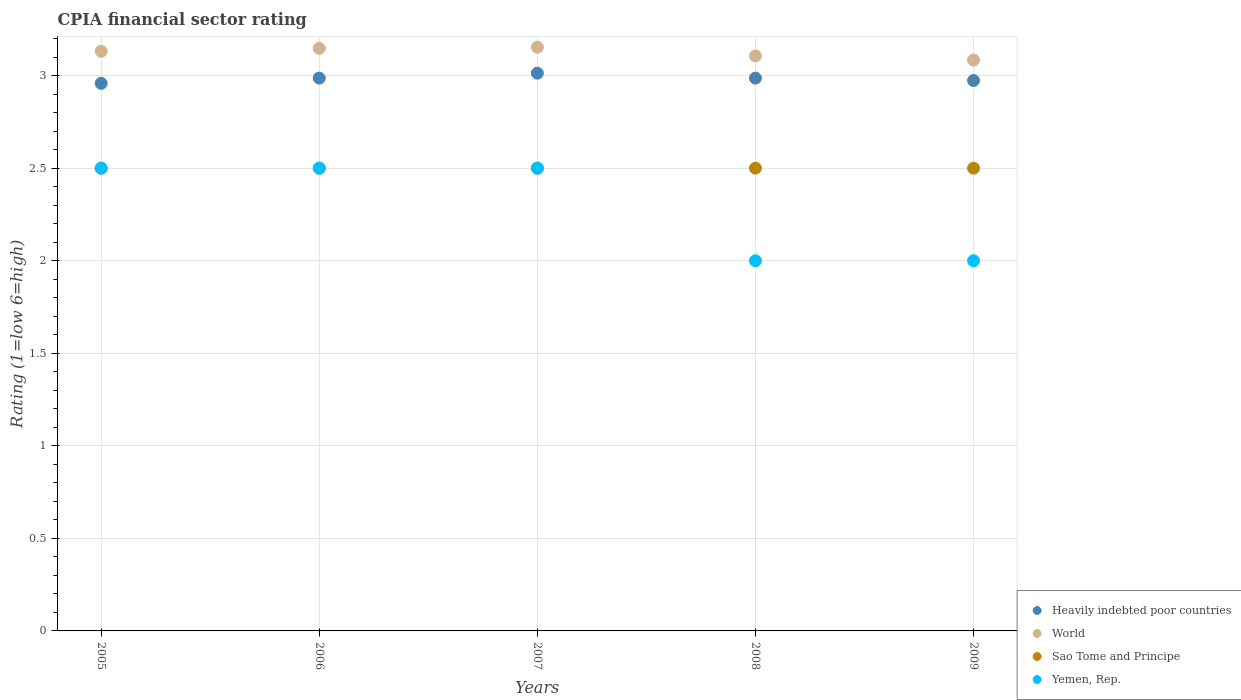Is the number of dotlines equal to the number of legend labels?
Provide a short and direct response. Yes. What is the CPIA rating in Yemen, Rep. in 2008?
Provide a succinct answer. 2. Across all years, what is the maximum CPIA rating in World?
Provide a short and direct response. 3.15. Across all years, what is the minimum CPIA rating in World?
Offer a very short reply. 3.08. In which year was the CPIA rating in World maximum?
Your response must be concise. 2007. In which year was the CPIA rating in Sao Tome and Principe minimum?
Make the answer very short. 2005. What is the total CPIA rating in World in the graph?
Provide a short and direct response. 15.62. What is the difference between the CPIA rating in Yemen, Rep. in 2006 and that in 2008?
Your answer should be compact. 0.5. What is the difference between the CPIA rating in World in 2007 and the CPIA rating in Yemen, Rep. in 2009?
Your answer should be compact. 1.15. In the year 2009, what is the difference between the CPIA rating in Heavily indebted poor countries and CPIA rating in World?
Give a very brief answer. -0.11. In how many years, is the CPIA rating in Yemen, Rep. greater than 1.2?
Your response must be concise. 5. What is the ratio of the CPIA rating in Yemen, Rep. in 2008 to that in 2009?
Offer a very short reply. 1. Is the CPIA rating in World in 2005 less than that in 2006?
Provide a short and direct response. Yes. What is the difference between the highest and the second highest CPIA rating in Heavily indebted poor countries?
Give a very brief answer. 0.03. What is the difference between the highest and the lowest CPIA rating in World?
Offer a very short reply. 0.07. Is it the case that in every year, the sum of the CPIA rating in World and CPIA rating in Heavily indebted poor countries  is greater than the sum of CPIA rating in Yemen, Rep. and CPIA rating in Sao Tome and Principe?
Ensure brevity in your answer.  No. Is the CPIA rating in Yemen, Rep. strictly greater than the CPIA rating in World over the years?
Your answer should be compact. No. Is the CPIA rating in Heavily indebted poor countries strictly less than the CPIA rating in Yemen, Rep. over the years?
Your answer should be compact. No. What is the difference between two consecutive major ticks on the Y-axis?
Offer a terse response. 0.5. Are the values on the major ticks of Y-axis written in scientific E-notation?
Make the answer very short. No. Does the graph contain grids?
Offer a terse response. Yes. Where does the legend appear in the graph?
Your response must be concise. Bottom right. How many legend labels are there?
Your response must be concise. 4. What is the title of the graph?
Provide a short and direct response. CPIA financial sector rating. What is the Rating (1=low 6=high) of Heavily indebted poor countries in 2005?
Your answer should be compact. 2.96. What is the Rating (1=low 6=high) in World in 2005?
Offer a terse response. 3.13. What is the Rating (1=low 6=high) of Sao Tome and Principe in 2005?
Provide a short and direct response. 2.5. What is the Rating (1=low 6=high) of Yemen, Rep. in 2005?
Offer a very short reply. 2.5. What is the Rating (1=low 6=high) in Heavily indebted poor countries in 2006?
Ensure brevity in your answer.  2.99. What is the Rating (1=low 6=high) of World in 2006?
Ensure brevity in your answer.  3.15. What is the Rating (1=low 6=high) in Sao Tome and Principe in 2006?
Ensure brevity in your answer.  2.5. What is the Rating (1=low 6=high) of Yemen, Rep. in 2006?
Your response must be concise. 2.5. What is the Rating (1=low 6=high) in Heavily indebted poor countries in 2007?
Ensure brevity in your answer.  3.01. What is the Rating (1=low 6=high) of World in 2007?
Your answer should be compact. 3.15. What is the Rating (1=low 6=high) of Sao Tome and Principe in 2007?
Provide a short and direct response. 2.5. What is the Rating (1=low 6=high) in Heavily indebted poor countries in 2008?
Keep it short and to the point. 2.99. What is the Rating (1=low 6=high) of World in 2008?
Provide a succinct answer. 3.11. What is the Rating (1=low 6=high) in Yemen, Rep. in 2008?
Make the answer very short. 2. What is the Rating (1=low 6=high) in Heavily indebted poor countries in 2009?
Ensure brevity in your answer.  2.97. What is the Rating (1=low 6=high) in World in 2009?
Offer a very short reply. 3.08. What is the Rating (1=low 6=high) in Yemen, Rep. in 2009?
Your response must be concise. 2. Across all years, what is the maximum Rating (1=low 6=high) of Heavily indebted poor countries?
Your response must be concise. 3.01. Across all years, what is the maximum Rating (1=low 6=high) in World?
Make the answer very short. 3.15. Across all years, what is the minimum Rating (1=low 6=high) of Heavily indebted poor countries?
Give a very brief answer. 2.96. Across all years, what is the minimum Rating (1=low 6=high) of World?
Offer a terse response. 3.08. Across all years, what is the minimum Rating (1=low 6=high) in Sao Tome and Principe?
Give a very brief answer. 2.5. What is the total Rating (1=low 6=high) of Heavily indebted poor countries in the graph?
Make the answer very short. 14.92. What is the total Rating (1=low 6=high) in World in the graph?
Make the answer very short. 15.62. What is the difference between the Rating (1=low 6=high) in Heavily indebted poor countries in 2005 and that in 2006?
Make the answer very short. -0.03. What is the difference between the Rating (1=low 6=high) of World in 2005 and that in 2006?
Offer a terse response. -0.02. What is the difference between the Rating (1=low 6=high) in Sao Tome and Principe in 2005 and that in 2006?
Your answer should be very brief. 0. What is the difference between the Rating (1=low 6=high) in Yemen, Rep. in 2005 and that in 2006?
Make the answer very short. 0. What is the difference between the Rating (1=low 6=high) of Heavily indebted poor countries in 2005 and that in 2007?
Offer a very short reply. -0.06. What is the difference between the Rating (1=low 6=high) of World in 2005 and that in 2007?
Provide a succinct answer. -0.02. What is the difference between the Rating (1=low 6=high) in Yemen, Rep. in 2005 and that in 2007?
Offer a very short reply. 0. What is the difference between the Rating (1=low 6=high) in Heavily indebted poor countries in 2005 and that in 2008?
Offer a very short reply. -0.03. What is the difference between the Rating (1=low 6=high) in World in 2005 and that in 2008?
Make the answer very short. 0.02. What is the difference between the Rating (1=low 6=high) in Yemen, Rep. in 2005 and that in 2008?
Ensure brevity in your answer.  0.5. What is the difference between the Rating (1=low 6=high) in Heavily indebted poor countries in 2005 and that in 2009?
Provide a short and direct response. -0.02. What is the difference between the Rating (1=low 6=high) of World in 2005 and that in 2009?
Ensure brevity in your answer.  0.05. What is the difference between the Rating (1=low 6=high) of Sao Tome and Principe in 2005 and that in 2009?
Offer a very short reply. 0. What is the difference between the Rating (1=low 6=high) in Heavily indebted poor countries in 2006 and that in 2007?
Give a very brief answer. -0.03. What is the difference between the Rating (1=low 6=high) of World in 2006 and that in 2007?
Your answer should be very brief. -0.01. What is the difference between the Rating (1=low 6=high) in World in 2006 and that in 2008?
Keep it short and to the point. 0.04. What is the difference between the Rating (1=low 6=high) in Heavily indebted poor countries in 2006 and that in 2009?
Offer a very short reply. 0.01. What is the difference between the Rating (1=low 6=high) of World in 2006 and that in 2009?
Your response must be concise. 0.06. What is the difference between the Rating (1=low 6=high) of Sao Tome and Principe in 2006 and that in 2009?
Offer a terse response. 0. What is the difference between the Rating (1=low 6=high) of Heavily indebted poor countries in 2007 and that in 2008?
Provide a succinct answer. 0.03. What is the difference between the Rating (1=low 6=high) in World in 2007 and that in 2008?
Offer a very short reply. 0.05. What is the difference between the Rating (1=low 6=high) of Yemen, Rep. in 2007 and that in 2008?
Provide a succinct answer. 0.5. What is the difference between the Rating (1=low 6=high) of Heavily indebted poor countries in 2007 and that in 2009?
Your response must be concise. 0.04. What is the difference between the Rating (1=low 6=high) in World in 2007 and that in 2009?
Provide a short and direct response. 0.07. What is the difference between the Rating (1=low 6=high) in Sao Tome and Principe in 2007 and that in 2009?
Keep it short and to the point. 0. What is the difference between the Rating (1=low 6=high) of Heavily indebted poor countries in 2008 and that in 2009?
Offer a terse response. 0.01. What is the difference between the Rating (1=low 6=high) of World in 2008 and that in 2009?
Your response must be concise. 0.02. What is the difference between the Rating (1=low 6=high) in Sao Tome and Principe in 2008 and that in 2009?
Provide a short and direct response. 0. What is the difference between the Rating (1=low 6=high) of Heavily indebted poor countries in 2005 and the Rating (1=low 6=high) of World in 2006?
Provide a short and direct response. -0.19. What is the difference between the Rating (1=low 6=high) in Heavily indebted poor countries in 2005 and the Rating (1=low 6=high) in Sao Tome and Principe in 2006?
Provide a short and direct response. 0.46. What is the difference between the Rating (1=low 6=high) of Heavily indebted poor countries in 2005 and the Rating (1=low 6=high) of Yemen, Rep. in 2006?
Your answer should be very brief. 0.46. What is the difference between the Rating (1=low 6=high) in World in 2005 and the Rating (1=low 6=high) in Sao Tome and Principe in 2006?
Provide a succinct answer. 0.63. What is the difference between the Rating (1=low 6=high) in World in 2005 and the Rating (1=low 6=high) in Yemen, Rep. in 2006?
Give a very brief answer. 0.63. What is the difference between the Rating (1=low 6=high) of Heavily indebted poor countries in 2005 and the Rating (1=low 6=high) of World in 2007?
Offer a very short reply. -0.2. What is the difference between the Rating (1=low 6=high) of Heavily indebted poor countries in 2005 and the Rating (1=low 6=high) of Sao Tome and Principe in 2007?
Keep it short and to the point. 0.46. What is the difference between the Rating (1=low 6=high) in Heavily indebted poor countries in 2005 and the Rating (1=low 6=high) in Yemen, Rep. in 2007?
Offer a terse response. 0.46. What is the difference between the Rating (1=low 6=high) of World in 2005 and the Rating (1=low 6=high) of Sao Tome and Principe in 2007?
Make the answer very short. 0.63. What is the difference between the Rating (1=low 6=high) in World in 2005 and the Rating (1=low 6=high) in Yemen, Rep. in 2007?
Your answer should be compact. 0.63. What is the difference between the Rating (1=low 6=high) of Heavily indebted poor countries in 2005 and the Rating (1=low 6=high) of World in 2008?
Keep it short and to the point. -0.15. What is the difference between the Rating (1=low 6=high) of Heavily indebted poor countries in 2005 and the Rating (1=low 6=high) of Sao Tome and Principe in 2008?
Give a very brief answer. 0.46. What is the difference between the Rating (1=low 6=high) of Heavily indebted poor countries in 2005 and the Rating (1=low 6=high) of Yemen, Rep. in 2008?
Offer a very short reply. 0.96. What is the difference between the Rating (1=low 6=high) in World in 2005 and the Rating (1=low 6=high) in Sao Tome and Principe in 2008?
Give a very brief answer. 0.63. What is the difference between the Rating (1=low 6=high) of World in 2005 and the Rating (1=low 6=high) of Yemen, Rep. in 2008?
Your answer should be compact. 1.13. What is the difference between the Rating (1=low 6=high) in Sao Tome and Principe in 2005 and the Rating (1=low 6=high) in Yemen, Rep. in 2008?
Offer a very short reply. 0.5. What is the difference between the Rating (1=low 6=high) of Heavily indebted poor countries in 2005 and the Rating (1=low 6=high) of World in 2009?
Give a very brief answer. -0.13. What is the difference between the Rating (1=low 6=high) in Heavily indebted poor countries in 2005 and the Rating (1=low 6=high) in Sao Tome and Principe in 2009?
Provide a succinct answer. 0.46. What is the difference between the Rating (1=low 6=high) of World in 2005 and the Rating (1=low 6=high) of Sao Tome and Principe in 2009?
Keep it short and to the point. 0.63. What is the difference between the Rating (1=low 6=high) in World in 2005 and the Rating (1=low 6=high) in Yemen, Rep. in 2009?
Your response must be concise. 1.13. What is the difference between the Rating (1=low 6=high) in Heavily indebted poor countries in 2006 and the Rating (1=low 6=high) in World in 2007?
Keep it short and to the point. -0.17. What is the difference between the Rating (1=low 6=high) in Heavily indebted poor countries in 2006 and the Rating (1=low 6=high) in Sao Tome and Principe in 2007?
Make the answer very short. 0.49. What is the difference between the Rating (1=low 6=high) of Heavily indebted poor countries in 2006 and the Rating (1=low 6=high) of Yemen, Rep. in 2007?
Your response must be concise. 0.49. What is the difference between the Rating (1=low 6=high) of World in 2006 and the Rating (1=low 6=high) of Sao Tome and Principe in 2007?
Keep it short and to the point. 0.65. What is the difference between the Rating (1=low 6=high) of World in 2006 and the Rating (1=low 6=high) of Yemen, Rep. in 2007?
Provide a short and direct response. 0.65. What is the difference between the Rating (1=low 6=high) in Heavily indebted poor countries in 2006 and the Rating (1=low 6=high) in World in 2008?
Keep it short and to the point. -0.12. What is the difference between the Rating (1=low 6=high) of Heavily indebted poor countries in 2006 and the Rating (1=low 6=high) of Sao Tome and Principe in 2008?
Provide a short and direct response. 0.49. What is the difference between the Rating (1=low 6=high) in Heavily indebted poor countries in 2006 and the Rating (1=low 6=high) in Yemen, Rep. in 2008?
Provide a succinct answer. 0.99. What is the difference between the Rating (1=low 6=high) in World in 2006 and the Rating (1=low 6=high) in Sao Tome and Principe in 2008?
Your response must be concise. 0.65. What is the difference between the Rating (1=low 6=high) in World in 2006 and the Rating (1=low 6=high) in Yemen, Rep. in 2008?
Your answer should be compact. 1.15. What is the difference between the Rating (1=low 6=high) of Sao Tome and Principe in 2006 and the Rating (1=low 6=high) of Yemen, Rep. in 2008?
Your answer should be very brief. 0.5. What is the difference between the Rating (1=low 6=high) of Heavily indebted poor countries in 2006 and the Rating (1=low 6=high) of World in 2009?
Offer a terse response. -0.1. What is the difference between the Rating (1=low 6=high) in Heavily indebted poor countries in 2006 and the Rating (1=low 6=high) in Sao Tome and Principe in 2009?
Make the answer very short. 0.49. What is the difference between the Rating (1=low 6=high) in Heavily indebted poor countries in 2006 and the Rating (1=low 6=high) in Yemen, Rep. in 2009?
Keep it short and to the point. 0.99. What is the difference between the Rating (1=low 6=high) of World in 2006 and the Rating (1=low 6=high) of Sao Tome and Principe in 2009?
Your answer should be compact. 0.65. What is the difference between the Rating (1=low 6=high) in World in 2006 and the Rating (1=low 6=high) in Yemen, Rep. in 2009?
Make the answer very short. 1.15. What is the difference between the Rating (1=low 6=high) in Heavily indebted poor countries in 2007 and the Rating (1=low 6=high) in World in 2008?
Ensure brevity in your answer.  -0.09. What is the difference between the Rating (1=low 6=high) of Heavily indebted poor countries in 2007 and the Rating (1=low 6=high) of Sao Tome and Principe in 2008?
Ensure brevity in your answer.  0.51. What is the difference between the Rating (1=low 6=high) in Heavily indebted poor countries in 2007 and the Rating (1=low 6=high) in Yemen, Rep. in 2008?
Give a very brief answer. 1.01. What is the difference between the Rating (1=low 6=high) in World in 2007 and the Rating (1=low 6=high) in Sao Tome and Principe in 2008?
Ensure brevity in your answer.  0.65. What is the difference between the Rating (1=low 6=high) of World in 2007 and the Rating (1=low 6=high) of Yemen, Rep. in 2008?
Provide a succinct answer. 1.15. What is the difference between the Rating (1=low 6=high) in Heavily indebted poor countries in 2007 and the Rating (1=low 6=high) in World in 2009?
Keep it short and to the point. -0.07. What is the difference between the Rating (1=low 6=high) of Heavily indebted poor countries in 2007 and the Rating (1=low 6=high) of Sao Tome and Principe in 2009?
Your answer should be very brief. 0.51. What is the difference between the Rating (1=low 6=high) in Heavily indebted poor countries in 2007 and the Rating (1=low 6=high) in Yemen, Rep. in 2009?
Ensure brevity in your answer.  1.01. What is the difference between the Rating (1=low 6=high) in World in 2007 and the Rating (1=low 6=high) in Sao Tome and Principe in 2009?
Make the answer very short. 0.65. What is the difference between the Rating (1=low 6=high) of World in 2007 and the Rating (1=low 6=high) of Yemen, Rep. in 2009?
Keep it short and to the point. 1.15. What is the difference between the Rating (1=low 6=high) of Heavily indebted poor countries in 2008 and the Rating (1=low 6=high) of World in 2009?
Keep it short and to the point. -0.1. What is the difference between the Rating (1=low 6=high) of Heavily indebted poor countries in 2008 and the Rating (1=low 6=high) of Sao Tome and Principe in 2009?
Offer a very short reply. 0.49. What is the difference between the Rating (1=low 6=high) of Heavily indebted poor countries in 2008 and the Rating (1=low 6=high) of Yemen, Rep. in 2009?
Offer a very short reply. 0.99. What is the difference between the Rating (1=low 6=high) of World in 2008 and the Rating (1=low 6=high) of Sao Tome and Principe in 2009?
Ensure brevity in your answer.  0.61. What is the difference between the Rating (1=low 6=high) in World in 2008 and the Rating (1=low 6=high) in Yemen, Rep. in 2009?
Your answer should be compact. 1.11. What is the difference between the Rating (1=low 6=high) of Sao Tome and Principe in 2008 and the Rating (1=low 6=high) of Yemen, Rep. in 2009?
Keep it short and to the point. 0.5. What is the average Rating (1=low 6=high) of Heavily indebted poor countries per year?
Your response must be concise. 2.98. What is the average Rating (1=low 6=high) of World per year?
Give a very brief answer. 3.12. What is the average Rating (1=low 6=high) in Sao Tome and Principe per year?
Provide a succinct answer. 2.5. In the year 2005, what is the difference between the Rating (1=low 6=high) of Heavily indebted poor countries and Rating (1=low 6=high) of World?
Your answer should be very brief. -0.17. In the year 2005, what is the difference between the Rating (1=low 6=high) of Heavily indebted poor countries and Rating (1=low 6=high) of Sao Tome and Principe?
Offer a very short reply. 0.46. In the year 2005, what is the difference between the Rating (1=low 6=high) in Heavily indebted poor countries and Rating (1=low 6=high) in Yemen, Rep.?
Provide a succinct answer. 0.46. In the year 2005, what is the difference between the Rating (1=low 6=high) of World and Rating (1=low 6=high) of Sao Tome and Principe?
Your answer should be compact. 0.63. In the year 2005, what is the difference between the Rating (1=low 6=high) in World and Rating (1=low 6=high) in Yemen, Rep.?
Ensure brevity in your answer.  0.63. In the year 2005, what is the difference between the Rating (1=low 6=high) in Sao Tome and Principe and Rating (1=low 6=high) in Yemen, Rep.?
Provide a succinct answer. 0. In the year 2006, what is the difference between the Rating (1=low 6=high) of Heavily indebted poor countries and Rating (1=low 6=high) of World?
Offer a terse response. -0.16. In the year 2006, what is the difference between the Rating (1=low 6=high) of Heavily indebted poor countries and Rating (1=low 6=high) of Sao Tome and Principe?
Keep it short and to the point. 0.49. In the year 2006, what is the difference between the Rating (1=low 6=high) of Heavily indebted poor countries and Rating (1=low 6=high) of Yemen, Rep.?
Ensure brevity in your answer.  0.49. In the year 2006, what is the difference between the Rating (1=low 6=high) of World and Rating (1=low 6=high) of Sao Tome and Principe?
Give a very brief answer. 0.65. In the year 2006, what is the difference between the Rating (1=low 6=high) of World and Rating (1=low 6=high) of Yemen, Rep.?
Provide a short and direct response. 0.65. In the year 2007, what is the difference between the Rating (1=low 6=high) of Heavily indebted poor countries and Rating (1=low 6=high) of World?
Provide a succinct answer. -0.14. In the year 2007, what is the difference between the Rating (1=low 6=high) in Heavily indebted poor countries and Rating (1=low 6=high) in Sao Tome and Principe?
Your answer should be compact. 0.51. In the year 2007, what is the difference between the Rating (1=low 6=high) of Heavily indebted poor countries and Rating (1=low 6=high) of Yemen, Rep.?
Ensure brevity in your answer.  0.51. In the year 2007, what is the difference between the Rating (1=low 6=high) in World and Rating (1=low 6=high) in Sao Tome and Principe?
Your answer should be very brief. 0.65. In the year 2007, what is the difference between the Rating (1=low 6=high) in World and Rating (1=low 6=high) in Yemen, Rep.?
Give a very brief answer. 0.65. In the year 2007, what is the difference between the Rating (1=low 6=high) in Sao Tome and Principe and Rating (1=low 6=high) in Yemen, Rep.?
Your answer should be compact. 0. In the year 2008, what is the difference between the Rating (1=low 6=high) in Heavily indebted poor countries and Rating (1=low 6=high) in World?
Make the answer very short. -0.12. In the year 2008, what is the difference between the Rating (1=low 6=high) of Heavily indebted poor countries and Rating (1=low 6=high) of Sao Tome and Principe?
Provide a short and direct response. 0.49. In the year 2008, what is the difference between the Rating (1=low 6=high) in Heavily indebted poor countries and Rating (1=low 6=high) in Yemen, Rep.?
Offer a terse response. 0.99. In the year 2008, what is the difference between the Rating (1=low 6=high) in World and Rating (1=low 6=high) in Sao Tome and Principe?
Provide a succinct answer. 0.61. In the year 2008, what is the difference between the Rating (1=low 6=high) of World and Rating (1=low 6=high) of Yemen, Rep.?
Make the answer very short. 1.11. In the year 2009, what is the difference between the Rating (1=low 6=high) of Heavily indebted poor countries and Rating (1=low 6=high) of World?
Offer a very short reply. -0.11. In the year 2009, what is the difference between the Rating (1=low 6=high) of Heavily indebted poor countries and Rating (1=low 6=high) of Sao Tome and Principe?
Keep it short and to the point. 0.47. In the year 2009, what is the difference between the Rating (1=low 6=high) of Heavily indebted poor countries and Rating (1=low 6=high) of Yemen, Rep.?
Make the answer very short. 0.97. In the year 2009, what is the difference between the Rating (1=low 6=high) in World and Rating (1=low 6=high) in Sao Tome and Principe?
Offer a terse response. 0.58. In the year 2009, what is the difference between the Rating (1=low 6=high) of World and Rating (1=low 6=high) of Yemen, Rep.?
Your response must be concise. 1.08. In the year 2009, what is the difference between the Rating (1=low 6=high) in Sao Tome and Principe and Rating (1=low 6=high) in Yemen, Rep.?
Offer a terse response. 0.5. What is the ratio of the Rating (1=low 6=high) of Heavily indebted poor countries in 2005 to that in 2006?
Offer a terse response. 0.99. What is the ratio of the Rating (1=low 6=high) of Sao Tome and Principe in 2005 to that in 2006?
Provide a short and direct response. 1. What is the ratio of the Rating (1=low 6=high) in Yemen, Rep. in 2005 to that in 2006?
Make the answer very short. 1. What is the ratio of the Rating (1=low 6=high) of Heavily indebted poor countries in 2005 to that in 2007?
Give a very brief answer. 0.98. What is the ratio of the Rating (1=low 6=high) in World in 2005 to that in 2007?
Your answer should be compact. 0.99. What is the ratio of the Rating (1=low 6=high) of Yemen, Rep. in 2005 to that in 2007?
Provide a short and direct response. 1. What is the ratio of the Rating (1=low 6=high) in Heavily indebted poor countries in 2005 to that in 2008?
Your answer should be very brief. 0.99. What is the ratio of the Rating (1=low 6=high) in World in 2005 to that in 2009?
Give a very brief answer. 1.02. What is the ratio of the Rating (1=low 6=high) of Heavily indebted poor countries in 2006 to that in 2007?
Provide a succinct answer. 0.99. What is the ratio of the Rating (1=low 6=high) of World in 2006 to that in 2008?
Make the answer very short. 1.01. What is the ratio of the Rating (1=low 6=high) of Sao Tome and Principe in 2006 to that in 2008?
Offer a very short reply. 1. What is the ratio of the Rating (1=low 6=high) of Heavily indebted poor countries in 2006 to that in 2009?
Make the answer very short. 1. What is the ratio of the Rating (1=low 6=high) of World in 2006 to that in 2009?
Offer a very short reply. 1.02. What is the ratio of the Rating (1=low 6=high) of Heavily indebted poor countries in 2007 to that in 2008?
Make the answer very short. 1.01. What is the ratio of the Rating (1=low 6=high) in World in 2007 to that in 2008?
Ensure brevity in your answer.  1.01. What is the ratio of the Rating (1=low 6=high) of Yemen, Rep. in 2007 to that in 2008?
Provide a short and direct response. 1.25. What is the ratio of the Rating (1=low 6=high) in Heavily indebted poor countries in 2007 to that in 2009?
Ensure brevity in your answer.  1.01. What is the ratio of the Rating (1=low 6=high) in World in 2007 to that in 2009?
Offer a terse response. 1.02. What is the ratio of the Rating (1=low 6=high) of Yemen, Rep. in 2007 to that in 2009?
Offer a very short reply. 1.25. What is the ratio of the Rating (1=low 6=high) of Sao Tome and Principe in 2008 to that in 2009?
Your response must be concise. 1. What is the difference between the highest and the second highest Rating (1=low 6=high) in Heavily indebted poor countries?
Your answer should be very brief. 0.03. What is the difference between the highest and the second highest Rating (1=low 6=high) in World?
Your response must be concise. 0.01. What is the difference between the highest and the lowest Rating (1=low 6=high) of Heavily indebted poor countries?
Provide a short and direct response. 0.06. What is the difference between the highest and the lowest Rating (1=low 6=high) of World?
Keep it short and to the point. 0.07. What is the difference between the highest and the lowest Rating (1=low 6=high) of Sao Tome and Principe?
Offer a terse response. 0. 